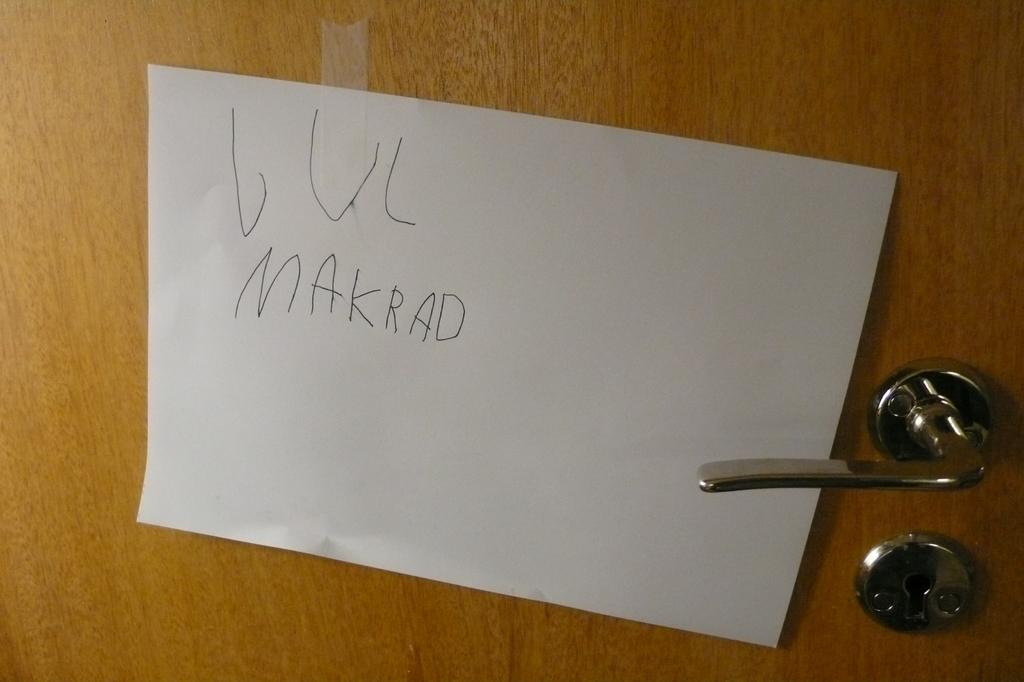What is attached to the door in the image? There is a paper with text written on it in the image. Can you describe the content of the paper? Unfortunately, the content of the paper cannot be determined from the image alone. What type of coach is visible in the image? There is no coach present in the image. What type of verse is written on the paper in the image? There is no indication of the content of the paper in the image, so it cannot be determined if it contains a verse. 